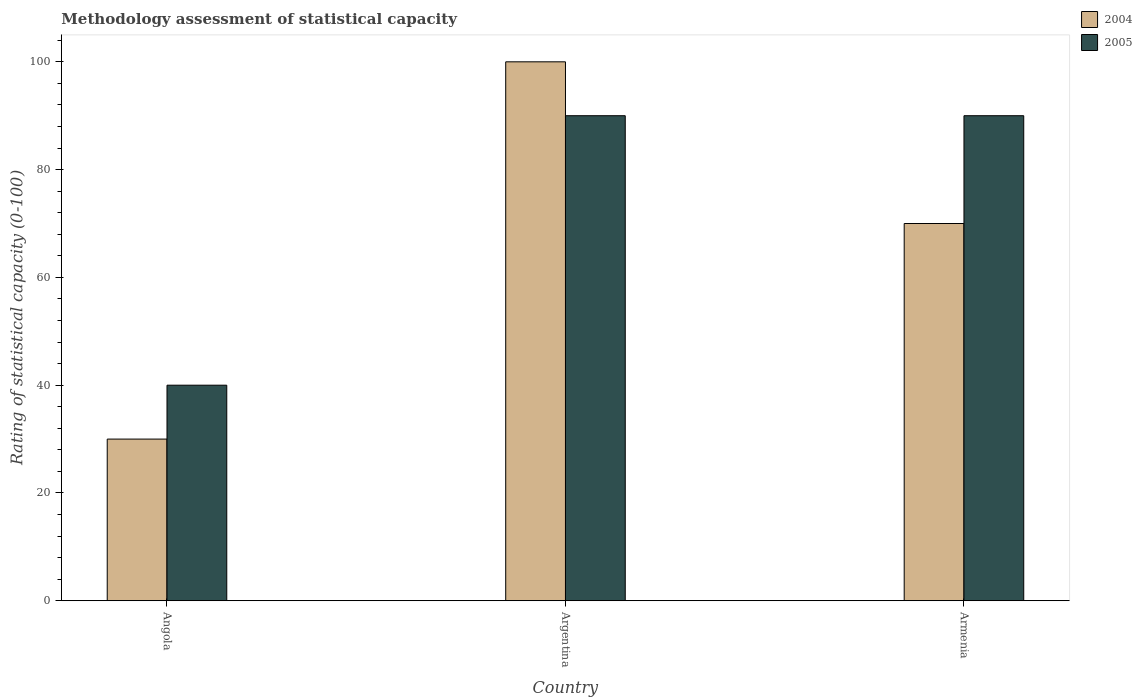How many different coloured bars are there?
Offer a terse response. 2. Are the number of bars on each tick of the X-axis equal?
Provide a short and direct response. Yes. How many bars are there on the 1st tick from the left?
Make the answer very short. 2. What is the label of the 2nd group of bars from the left?
Your answer should be very brief. Argentina. In which country was the rating of statistical capacity in 2005 minimum?
Provide a succinct answer. Angola. What is the difference between the rating of statistical capacity in 2005 in Armenia and the rating of statistical capacity in 2004 in Angola?
Your answer should be compact. 60. What is the average rating of statistical capacity in 2004 per country?
Your answer should be very brief. 66.67. What is the difference between the rating of statistical capacity of/in 2004 and rating of statistical capacity of/in 2005 in Angola?
Provide a short and direct response. -10. In how many countries, is the rating of statistical capacity in 2005 greater than 72?
Ensure brevity in your answer.  2. What is the ratio of the rating of statistical capacity in 2005 in Argentina to that in Armenia?
Provide a short and direct response. 1. What is the difference between the highest and the second highest rating of statistical capacity in 2004?
Your answer should be compact. 30. In how many countries, is the rating of statistical capacity in 2004 greater than the average rating of statistical capacity in 2004 taken over all countries?
Provide a succinct answer. 2. Is the sum of the rating of statistical capacity in 2005 in Argentina and Armenia greater than the maximum rating of statistical capacity in 2004 across all countries?
Give a very brief answer. Yes. What does the 2nd bar from the left in Armenia represents?
Ensure brevity in your answer.  2005. How many countries are there in the graph?
Offer a terse response. 3. Does the graph contain grids?
Your answer should be very brief. No. Where does the legend appear in the graph?
Ensure brevity in your answer.  Top right. How are the legend labels stacked?
Make the answer very short. Vertical. What is the title of the graph?
Your answer should be compact. Methodology assessment of statistical capacity. What is the label or title of the Y-axis?
Offer a terse response. Rating of statistical capacity (0-100). What is the Rating of statistical capacity (0-100) in 2004 in Angola?
Give a very brief answer. 30. What is the Rating of statistical capacity (0-100) in 2004 in Argentina?
Ensure brevity in your answer.  100. What is the Rating of statistical capacity (0-100) in 2004 in Armenia?
Keep it short and to the point. 70. What is the total Rating of statistical capacity (0-100) in 2005 in the graph?
Provide a short and direct response. 220. What is the difference between the Rating of statistical capacity (0-100) of 2004 in Angola and that in Argentina?
Your answer should be compact. -70. What is the difference between the Rating of statistical capacity (0-100) of 2004 in Angola and that in Armenia?
Make the answer very short. -40. What is the difference between the Rating of statistical capacity (0-100) of 2005 in Angola and that in Armenia?
Give a very brief answer. -50. What is the difference between the Rating of statistical capacity (0-100) of 2004 in Angola and the Rating of statistical capacity (0-100) of 2005 in Argentina?
Provide a short and direct response. -60. What is the difference between the Rating of statistical capacity (0-100) in 2004 in Angola and the Rating of statistical capacity (0-100) in 2005 in Armenia?
Keep it short and to the point. -60. What is the average Rating of statistical capacity (0-100) in 2004 per country?
Your answer should be compact. 66.67. What is the average Rating of statistical capacity (0-100) of 2005 per country?
Your response must be concise. 73.33. What is the difference between the Rating of statistical capacity (0-100) of 2004 and Rating of statistical capacity (0-100) of 2005 in Argentina?
Provide a succinct answer. 10. What is the difference between the Rating of statistical capacity (0-100) of 2004 and Rating of statistical capacity (0-100) of 2005 in Armenia?
Your answer should be very brief. -20. What is the ratio of the Rating of statistical capacity (0-100) in 2004 in Angola to that in Argentina?
Provide a succinct answer. 0.3. What is the ratio of the Rating of statistical capacity (0-100) of 2005 in Angola to that in Argentina?
Keep it short and to the point. 0.44. What is the ratio of the Rating of statistical capacity (0-100) in 2004 in Angola to that in Armenia?
Your response must be concise. 0.43. What is the ratio of the Rating of statistical capacity (0-100) of 2005 in Angola to that in Armenia?
Keep it short and to the point. 0.44. What is the ratio of the Rating of statistical capacity (0-100) of 2004 in Argentina to that in Armenia?
Your answer should be very brief. 1.43. What is the ratio of the Rating of statistical capacity (0-100) in 2005 in Argentina to that in Armenia?
Make the answer very short. 1. What is the difference between the highest and the second highest Rating of statistical capacity (0-100) in 2004?
Your response must be concise. 30. What is the difference between the highest and the lowest Rating of statistical capacity (0-100) in 2005?
Ensure brevity in your answer.  50. 